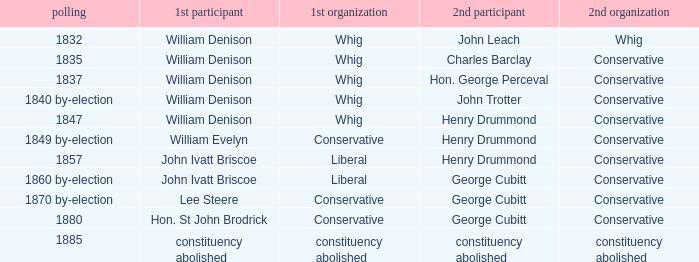Which party's 1st member is William Denison in the election of 1832? Whig. 